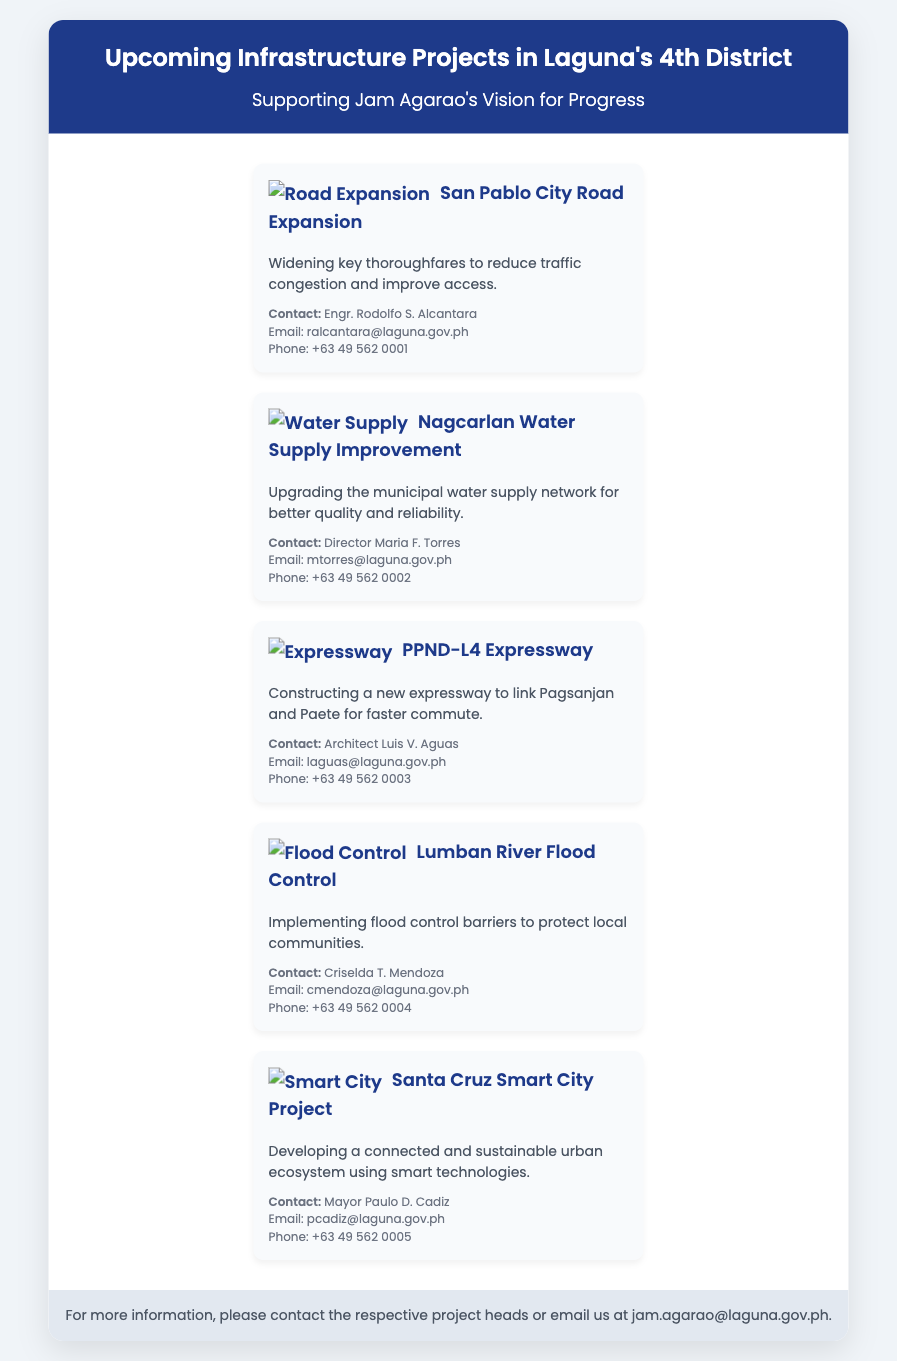What is the title of the document? The title is specified in the document header, summarizing the main theme of the content.
Answer: Upcoming Infrastructure Projects - Laguna's 4th District Who is the contact for the San Pablo City Road Expansion? The document lists the name and title of the person responsible for this project under the project details.
Answer: Engr. Rodolfo S. Alcantara What is the main goal of the Nagcarlan Water Supply Improvement? The document provides a brief description of the project's objective as stated in the project section.
Answer: Better quality and reliability How many projects are listed in the card? The document includes distinct sections for each project, allowing for a count of the projects mentioned.
Answer: Five Who is the Mayor associated with the Santa Cruz Smart City Project? This information is located in the contact section specifically related to the Santa Cruz Smart City Project.
Answer: Mayor Paulo D. Cadiz What type of icon is associated with the Lumban River Flood Control project? The document includes icons for visual differentiation of each project, specifically for Lumban River Flood Control.
Answer: Flood Control What is the email contact for the Director managing the water supply project? The document specifies contact information, including email addresses for project heads.
Answer: mtorres@laguna.gov.ph What project aims to connect Pagsanjan and Paete? The document provides project titles that signify the objectives behind each initiative.
Answer: PPND-L4 Expressway 